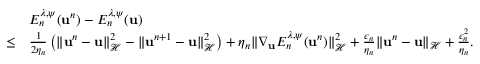Convert formula to latex. <formula><loc_0><loc_0><loc_500><loc_500>\begin{array} { r l } & { E _ { n } ^ { \lambda , \psi } ( { u } ^ { n } ) - E _ { n } ^ { \lambda , \psi } ( { u } ) } \\ { \leq } & { \frac { 1 } { 2 \eta _ { n } } \left ( \| { u } ^ { n } - { u } \| _ { \mathcal { H } } ^ { 2 } - \| { u } ^ { n + 1 } - { u } \| _ { \mathcal { H } } ^ { 2 } \right ) + \eta _ { n } \| \nabla _ { u } E _ { n } ^ { \lambda , \psi } ( { u } ^ { n } ) \| _ { \mathcal { H } } ^ { 2 } + \frac { \epsilon _ { n } } { \eta _ { n } } \| { u } ^ { n } - { u } \| _ { \mathcal { H } } + \frac { \epsilon _ { n } ^ { 2 } } { \eta _ { n } } . } \end{array}</formula> 